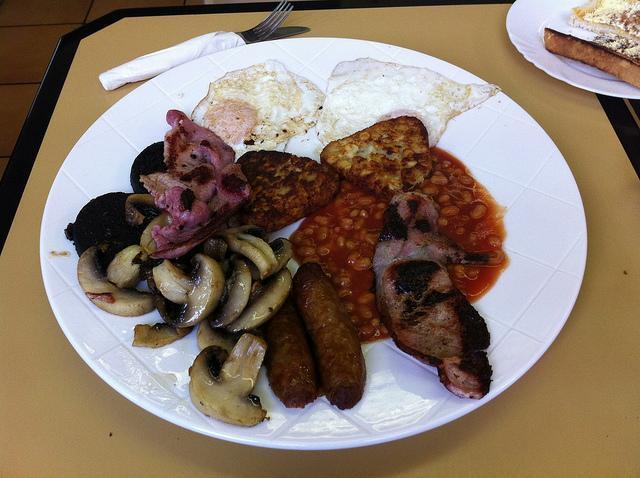How many people are standing on the hill?
Give a very brief answer. 0. 